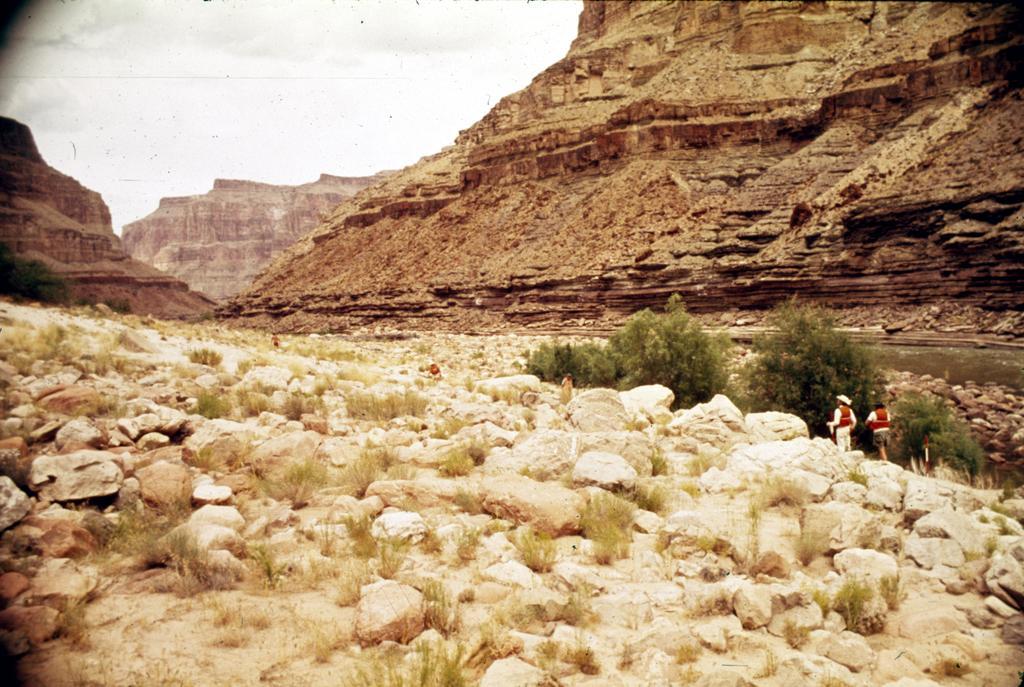How would you summarize this image in a sentence or two? In this image I can see rocks and plants. There are people standing and there is water on the right. There are mountains at the back. There is sky at the top. 